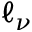Convert formula to latex. <formula><loc_0><loc_0><loc_500><loc_500>\ell _ { \nu }</formula> 